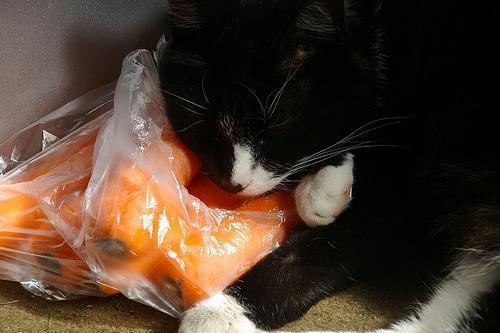How many cats are seen?
Give a very brief answer. 1. 